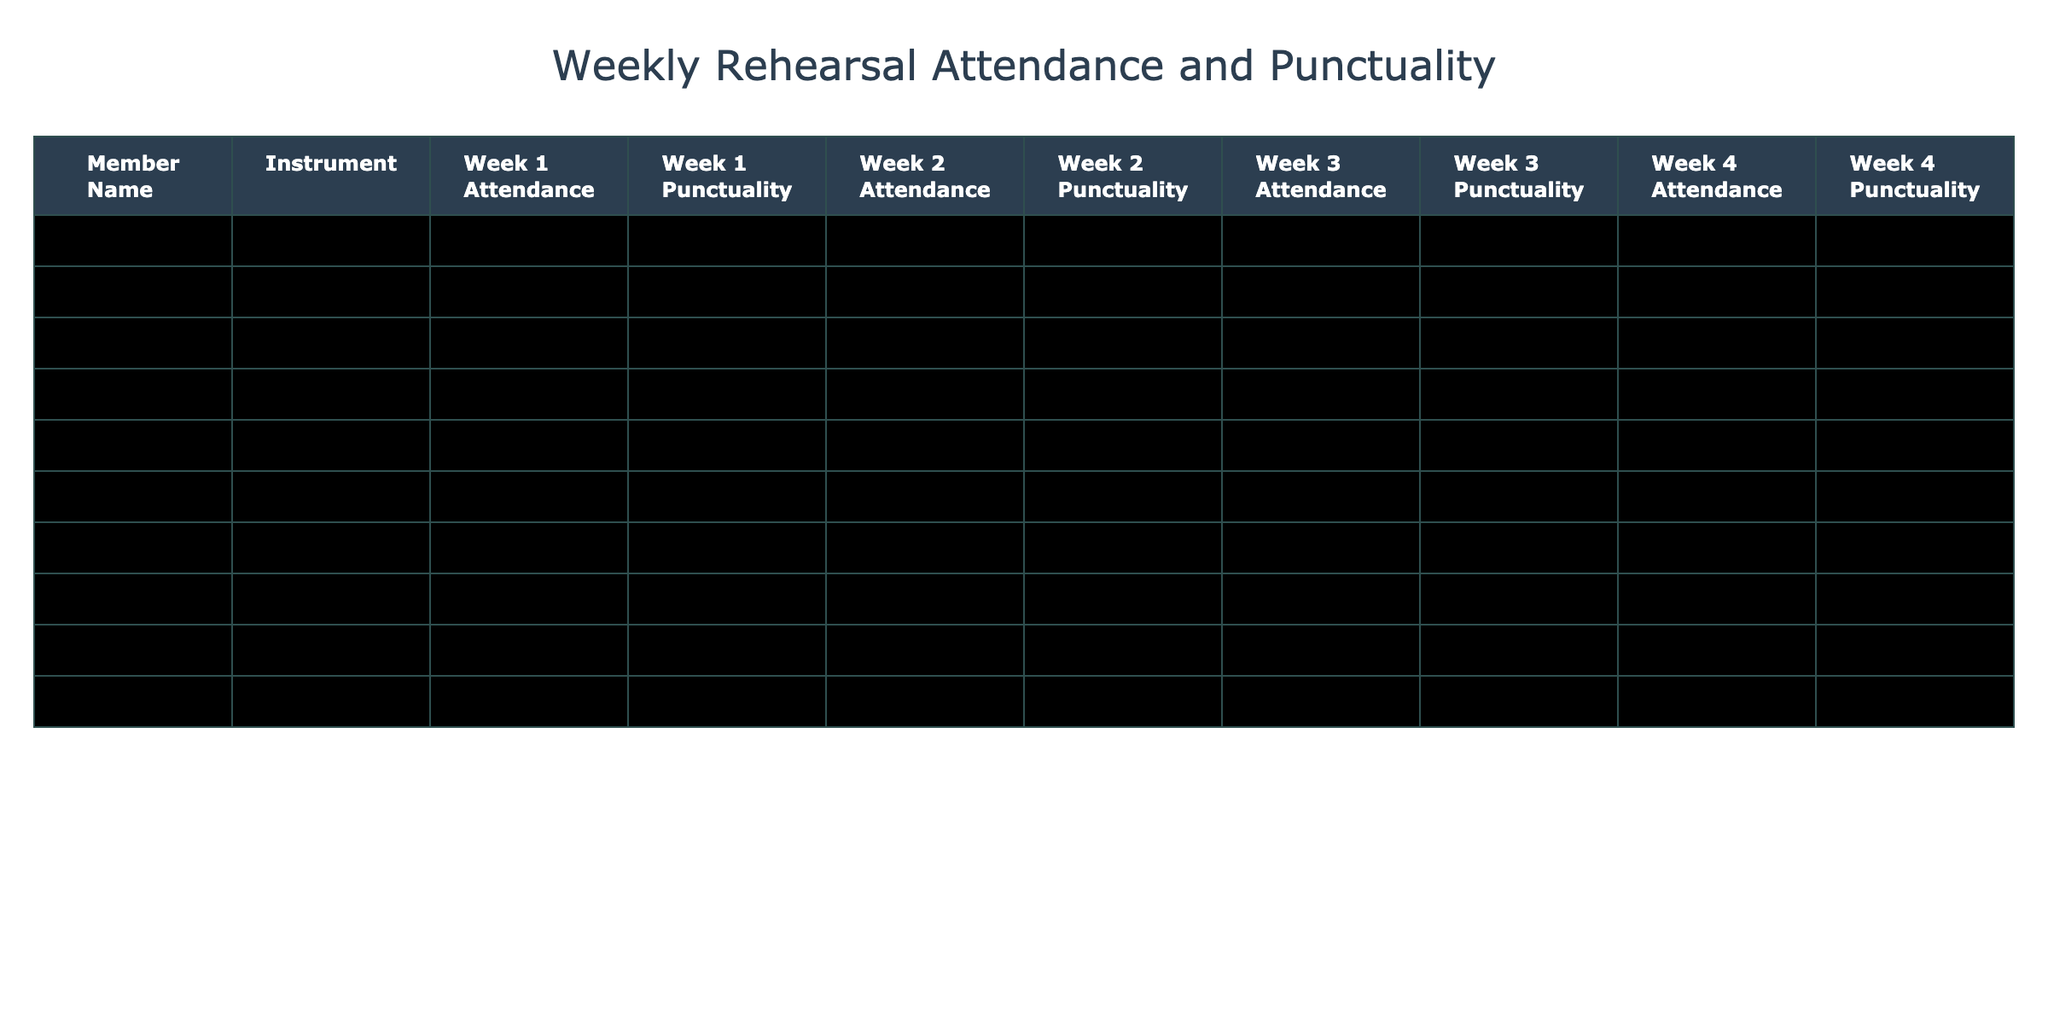What is the attendance status for Jack Lee in Week 2? Jack Lee's Week 2 Attendance value is recorded in the table, which indicates that he did not attend.
Answer: No How many weeks did Emily Davis attend on time? Emily Davis's attendance is labeled "On Time" for all four weeks. We count the occurrences: Week 1 (On Time), Week 2 (On Time), Week 3 (On Time), and Week 4 (On Time), yielding a total of four weeks.
Answer: 4 Which member had the most instances of being late? To find out who has the most "Late" entries, I review the attendance and punctuality across all weeks. Catherine Li and Grace Kim each had two "Late" statuses over the weeks, making them tied for the most instances of being late.
Answer: Catherine Li and Grace Kim Did any member have perfect attendance over the four weeks? I assess each member's attendance throughout the weeks, looking for anyone who has "Yes" for attendance in all weeks. Only Emily Davis meets this criteria with "Yes" in Weeks 1, 2, 3, and 4.
Answer: Yes What was the punctuality status for Isabella Martinez in Week 4? Looking at Isabella Martinez's data in week 4, her punctuality status is recorded as "Late."
Answer: Late How many members attended at least three weeks in total? I count the number of "Yes" responses in the attendance columns for each member. Brian Smith, Catherine Li, Frank Wilson, Isabella Martinez, and few others meet this criterion having the total of "Yes" adding up to three or more weeks. In total, there are four members.
Answer: 4 Which instrument had the highest average punctuality across all weeks? To determine this, I categorize the punctuality status into a numerical system (On Time = 1, Late = 0), and average the scores for each instrument. Calculating this leads to the conclusion that the Violin section has the highest average score.
Answer: Violin What is the total number of "No" attendance responses across all members? I review the attendance data, counting the occurrences of "No." There are two instances where the attendance status is marked "No" throughout. Thus, the total number is collected.
Answer: 2 